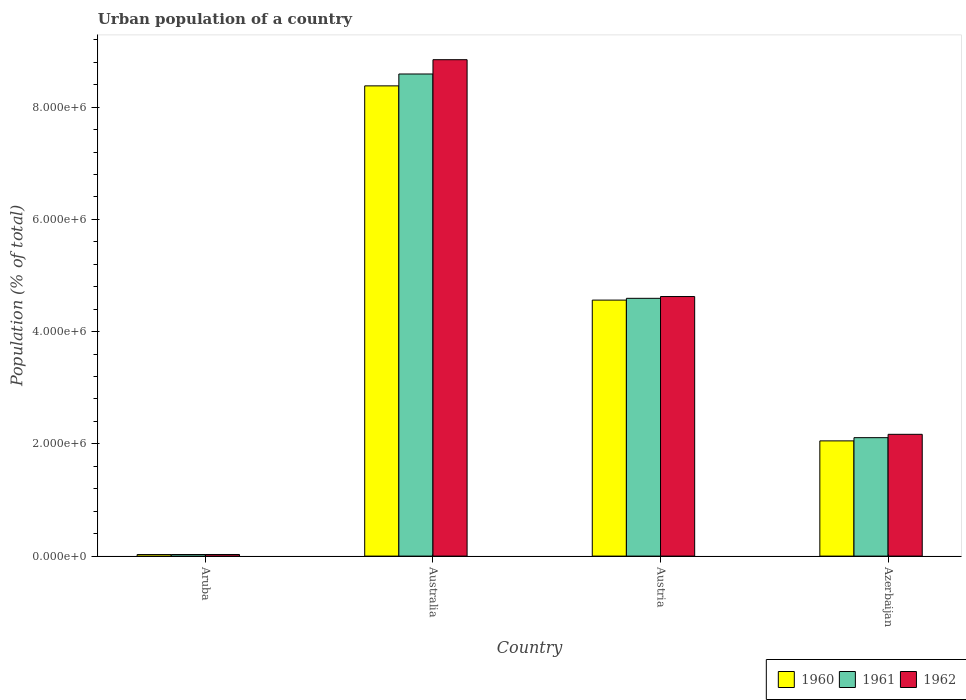How many groups of bars are there?
Your answer should be compact. 4. Are the number of bars per tick equal to the number of legend labels?
Keep it short and to the point. Yes. How many bars are there on the 1st tick from the right?
Provide a succinct answer. 3. In how many cases, is the number of bars for a given country not equal to the number of legend labels?
Your response must be concise. 0. What is the urban population in 1962 in Aruba?
Your response must be concise. 2.85e+04. Across all countries, what is the maximum urban population in 1961?
Provide a succinct answer. 8.59e+06. Across all countries, what is the minimum urban population in 1960?
Offer a very short reply. 2.75e+04. In which country was the urban population in 1962 minimum?
Provide a short and direct response. Aruba. What is the total urban population in 1960 in the graph?
Provide a short and direct response. 1.50e+07. What is the difference between the urban population in 1962 in Austria and that in Azerbaijan?
Offer a very short reply. 2.45e+06. What is the difference between the urban population in 1961 in Australia and the urban population in 1960 in Austria?
Provide a succinct answer. 4.03e+06. What is the average urban population in 1960 per country?
Your answer should be compact. 3.75e+06. What is the difference between the urban population of/in 1961 and urban population of/in 1960 in Australia?
Make the answer very short. 2.12e+05. What is the ratio of the urban population in 1960 in Australia to that in Azerbaijan?
Your answer should be very brief. 4.08. What is the difference between the highest and the second highest urban population in 1960?
Provide a succinct answer. -6.33e+06. What is the difference between the highest and the lowest urban population in 1961?
Keep it short and to the point. 8.56e+06. In how many countries, is the urban population in 1961 greater than the average urban population in 1961 taken over all countries?
Offer a very short reply. 2. Is the sum of the urban population in 1962 in Austria and Azerbaijan greater than the maximum urban population in 1961 across all countries?
Your answer should be compact. No. What does the 1st bar from the left in Aruba represents?
Your answer should be very brief. 1960. Are the values on the major ticks of Y-axis written in scientific E-notation?
Ensure brevity in your answer.  Yes. Does the graph contain any zero values?
Provide a succinct answer. No. Does the graph contain grids?
Provide a short and direct response. No. Where does the legend appear in the graph?
Your response must be concise. Bottom right. How many legend labels are there?
Ensure brevity in your answer.  3. What is the title of the graph?
Your answer should be very brief. Urban population of a country. What is the label or title of the X-axis?
Your answer should be compact. Country. What is the label or title of the Y-axis?
Ensure brevity in your answer.  Population (% of total). What is the Population (% of total) in 1960 in Aruba?
Make the answer very short. 2.75e+04. What is the Population (% of total) of 1961 in Aruba?
Your answer should be compact. 2.81e+04. What is the Population (% of total) in 1962 in Aruba?
Offer a very short reply. 2.85e+04. What is the Population (% of total) of 1960 in Australia?
Give a very brief answer. 8.38e+06. What is the Population (% of total) in 1961 in Australia?
Your response must be concise. 8.59e+06. What is the Population (% of total) in 1962 in Australia?
Your response must be concise. 8.84e+06. What is the Population (% of total) in 1960 in Austria?
Your answer should be very brief. 4.56e+06. What is the Population (% of total) in 1961 in Austria?
Your answer should be very brief. 4.59e+06. What is the Population (% of total) in 1962 in Austria?
Keep it short and to the point. 4.62e+06. What is the Population (% of total) of 1960 in Azerbaijan?
Your response must be concise. 2.05e+06. What is the Population (% of total) in 1961 in Azerbaijan?
Offer a terse response. 2.11e+06. What is the Population (% of total) in 1962 in Azerbaijan?
Make the answer very short. 2.17e+06. Across all countries, what is the maximum Population (% of total) in 1960?
Keep it short and to the point. 8.38e+06. Across all countries, what is the maximum Population (% of total) of 1961?
Your response must be concise. 8.59e+06. Across all countries, what is the maximum Population (% of total) in 1962?
Make the answer very short. 8.84e+06. Across all countries, what is the minimum Population (% of total) in 1960?
Offer a terse response. 2.75e+04. Across all countries, what is the minimum Population (% of total) in 1961?
Your answer should be compact. 2.81e+04. Across all countries, what is the minimum Population (% of total) of 1962?
Offer a terse response. 2.85e+04. What is the total Population (% of total) in 1960 in the graph?
Make the answer very short. 1.50e+07. What is the total Population (% of total) in 1961 in the graph?
Make the answer very short. 1.53e+07. What is the total Population (% of total) of 1962 in the graph?
Your answer should be compact. 1.57e+07. What is the difference between the Population (% of total) of 1960 in Aruba and that in Australia?
Provide a short and direct response. -8.35e+06. What is the difference between the Population (% of total) in 1961 in Aruba and that in Australia?
Offer a terse response. -8.56e+06. What is the difference between the Population (% of total) in 1962 in Aruba and that in Australia?
Provide a short and direct response. -8.82e+06. What is the difference between the Population (% of total) in 1960 in Aruba and that in Austria?
Your response must be concise. -4.53e+06. What is the difference between the Population (% of total) of 1961 in Aruba and that in Austria?
Your answer should be very brief. -4.56e+06. What is the difference between the Population (% of total) of 1962 in Aruba and that in Austria?
Provide a short and direct response. -4.60e+06. What is the difference between the Population (% of total) in 1960 in Aruba and that in Azerbaijan?
Offer a terse response. -2.03e+06. What is the difference between the Population (% of total) in 1961 in Aruba and that in Azerbaijan?
Provide a succinct answer. -2.08e+06. What is the difference between the Population (% of total) of 1962 in Aruba and that in Azerbaijan?
Your answer should be very brief. -2.14e+06. What is the difference between the Population (% of total) of 1960 in Australia and that in Austria?
Your answer should be very brief. 3.82e+06. What is the difference between the Population (% of total) in 1961 in Australia and that in Austria?
Offer a very short reply. 4.00e+06. What is the difference between the Population (% of total) in 1962 in Australia and that in Austria?
Make the answer very short. 4.22e+06. What is the difference between the Population (% of total) of 1960 in Australia and that in Azerbaijan?
Make the answer very short. 6.33e+06. What is the difference between the Population (% of total) of 1961 in Australia and that in Azerbaijan?
Provide a short and direct response. 6.48e+06. What is the difference between the Population (% of total) in 1962 in Australia and that in Azerbaijan?
Ensure brevity in your answer.  6.67e+06. What is the difference between the Population (% of total) in 1960 in Austria and that in Azerbaijan?
Give a very brief answer. 2.51e+06. What is the difference between the Population (% of total) in 1961 in Austria and that in Azerbaijan?
Keep it short and to the point. 2.48e+06. What is the difference between the Population (% of total) in 1962 in Austria and that in Azerbaijan?
Keep it short and to the point. 2.45e+06. What is the difference between the Population (% of total) of 1960 in Aruba and the Population (% of total) of 1961 in Australia?
Give a very brief answer. -8.56e+06. What is the difference between the Population (% of total) in 1960 in Aruba and the Population (% of total) in 1962 in Australia?
Ensure brevity in your answer.  -8.82e+06. What is the difference between the Population (% of total) of 1961 in Aruba and the Population (% of total) of 1962 in Australia?
Make the answer very short. -8.82e+06. What is the difference between the Population (% of total) in 1960 in Aruba and the Population (% of total) in 1961 in Austria?
Provide a short and direct response. -4.57e+06. What is the difference between the Population (% of total) of 1960 in Aruba and the Population (% of total) of 1962 in Austria?
Your answer should be very brief. -4.60e+06. What is the difference between the Population (% of total) of 1961 in Aruba and the Population (% of total) of 1962 in Austria?
Ensure brevity in your answer.  -4.60e+06. What is the difference between the Population (% of total) of 1960 in Aruba and the Population (% of total) of 1961 in Azerbaijan?
Provide a succinct answer. -2.08e+06. What is the difference between the Population (% of total) of 1960 in Aruba and the Population (% of total) of 1962 in Azerbaijan?
Keep it short and to the point. -2.14e+06. What is the difference between the Population (% of total) in 1961 in Aruba and the Population (% of total) in 1962 in Azerbaijan?
Your response must be concise. -2.14e+06. What is the difference between the Population (% of total) in 1960 in Australia and the Population (% of total) in 1961 in Austria?
Keep it short and to the point. 3.79e+06. What is the difference between the Population (% of total) in 1960 in Australia and the Population (% of total) in 1962 in Austria?
Ensure brevity in your answer.  3.75e+06. What is the difference between the Population (% of total) of 1961 in Australia and the Population (% of total) of 1962 in Austria?
Ensure brevity in your answer.  3.97e+06. What is the difference between the Population (% of total) of 1960 in Australia and the Population (% of total) of 1961 in Azerbaijan?
Provide a short and direct response. 6.27e+06. What is the difference between the Population (% of total) in 1960 in Australia and the Population (% of total) in 1962 in Azerbaijan?
Your answer should be compact. 6.21e+06. What is the difference between the Population (% of total) in 1961 in Australia and the Population (% of total) in 1962 in Azerbaijan?
Ensure brevity in your answer.  6.42e+06. What is the difference between the Population (% of total) of 1960 in Austria and the Population (% of total) of 1961 in Azerbaijan?
Provide a succinct answer. 2.45e+06. What is the difference between the Population (% of total) in 1960 in Austria and the Population (% of total) in 1962 in Azerbaijan?
Your answer should be compact. 2.39e+06. What is the difference between the Population (% of total) of 1961 in Austria and the Population (% of total) of 1962 in Azerbaijan?
Ensure brevity in your answer.  2.42e+06. What is the average Population (% of total) in 1960 per country?
Your response must be concise. 3.75e+06. What is the average Population (% of total) in 1961 per country?
Provide a short and direct response. 3.83e+06. What is the average Population (% of total) of 1962 per country?
Your answer should be very brief. 3.92e+06. What is the difference between the Population (% of total) in 1960 and Population (% of total) in 1961 in Aruba?
Your answer should be very brief. -614. What is the difference between the Population (% of total) in 1960 and Population (% of total) in 1962 in Aruba?
Your answer should be very brief. -1007. What is the difference between the Population (% of total) of 1961 and Population (% of total) of 1962 in Aruba?
Ensure brevity in your answer.  -393. What is the difference between the Population (% of total) in 1960 and Population (% of total) in 1961 in Australia?
Your answer should be compact. -2.12e+05. What is the difference between the Population (% of total) in 1960 and Population (% of total) in 1962 in Australia?
Your answer should be compact. -4.66e+05. What is the difference between the Population (% of total) in 1961 and Population (% of total) in 1962 in Australia?
Provide a succinct answer. -2.55e+05. What is the difference between the Population (% of total) of 1960 and Population (% of total) of 1961 in Austria?
Your answer should be compact. -3.17e+04. What is the difference between the Population (% of total) of 1960 and Population (% of total) of 1962 in Austria?
Offer a very short reply. -6.35e+04. What is the difference between the Population (% of total) of 1961 and Population (% of total) of 1962 in Austria?
Your answer should be compact. -3.17e+04. What is the difference between the Population (% of total) of 1960 and Population (% of total) of 1961 in Azerbaijan?
Offer a terse response. -5.76e+04. What is the difference between the Population (% of total) of 1960 and Population (% of total) of 1962 in Azerbaijan?
Ensure brevity in your answer.  -1.17e+05. What is the difference between the Population (% of total) in 1961 and Population (% of total) in 1962 in Azerbaijan?
Give a very brief answer. -5.95e+04. What is the ratio of the Population (% of total) in 1960 in Aruba to that in Australia?
Your response must be concise. 0. What is the ratio of the Population (% of total) in 1961 in Aruba to that in Australia?
Keep it short and to the point. 0. What is the ratio of the Population (% of total) in 1962 in Aruba to that in Australia?
Provide a short and direct response. 0. What is the ratio of the Population (% of total) in 1960 in Aruba to that in Austria?
Offer a very short reply. 0.01. What is the ratio of the Population (% of total) of 1961 in Aruba to that in Austria?
Provide a succinct answer. 0.01. What is the ratio of the Population (% of total) in 1962 in Aruba to that in Austria?
Give a very brief answer. 0.01. What is the ratio of the Population (% of total) of 1960 in Aruba to that in Azerbaijan?
Your answer should be compact. 0.01. What is the ratio of the Population (% of total) in 1961 in Aruba to that in Azerbaijan?
Your answer should be very brief. 0.01. What is the ratio of the Population (% of total) of 1962 in Aruba to that in Azerbaijan?
Offer a very short reply. 0.01. What is the ratio of the Population (% of total) in 1960 in Australia to that in Austria?
Your answer should be very brief. 1.84. What is the ratio of the Population (% of total) of 1961 in Australia to that in Austria?
Give a very brief answer. 1.87. What is the ratio of the Population (% of total) of 1962 in Australia to that in Austria?
Give a very brief answer. 1.91. What is the ratio of the Population (% of total) of 1960 in Australia to that in Azerbaijan?
Provide a short and direct response. 4.08. What is the ratio of the Population (% of total) of 1961 in Australia to that in Azerbaijan?
Make the answer very short. 4.07. What is the ratio of the Population (% of total) of 1962 in Australia to that in Azerbaijan?
Your response must be concise. 4.08. What is the ratio of the Population (% of total) of 1960 in Austria to that in Azerbaijan?
Keep it short and to the point. 2.22. What is the ratio of the Population (% of total) of 1961 in Austria to that in Azerbaijan?
Make the answer very short. 2.18. What is the ratio of the Population (% of total) of 1962 in Austria to that in Azerbaijan?
Give a very brief answer. 2.13. What is the difference between the highest and the second highest Population (% of total) in 1960?
Your answer should be very brief. 3.82e+06. What is the difference between the highest and the second highest Population (% of total) of 1961?
Your answer should be compact. 4.00e+06. What is the difference between the highest and the second highest Population (% of total) of 1962?
Offer a terse response. 4.22e+06. What is the difference between the highest and the lowest Population (% of total) of 1960?
Ensure brevity in your answer.  8.35e+06. What is the difference between the highest and the lowest Population (% of total) in 1961?
Provide a succinct answer. 8.56e+06. What is the difference between the highest and the lowest Population (% of total) in 1962?
Your answer should be compact. 8.82e+06. 